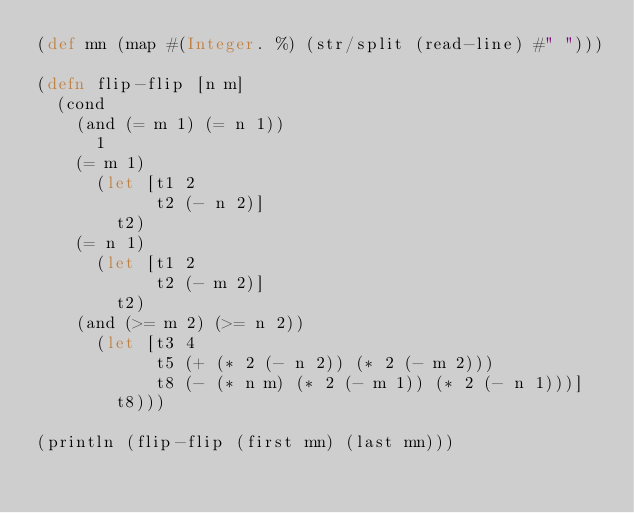Convert code to text. <code><loc_0><loc_0><loc_500><loc_500><_Clojure_>(def mn (map #(Integer. %) (str/split (read-line) #" ")))

(defn flip-flip [n m]
  (cond
    (and (= m 1) (= n 1))
      1
    (= m 1)
      (let [t1 2
            t2 (- n 2)]
        t2)
    (= n 1)
      (let [t1 2
            t2 (- m 2)]
        t2)
    (and (>= m 2) (>= n 2))
      (let [t3 4
            t5 (+ (* 2 (- n 2)) (* 2 (- m 2)))
            t8 (- (* n m) (* 2 (- m 1)) (* 2 (- n 1)))]
        t8)))

(println (flip-flip (first mn) (last mn)))
</code> 